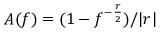Convert formula to latex. <formula><loc_0><loc_0><loc_500><loc_500>A ( f ) = ( 1 - f ^ { - \frac { r } { 2 } } ) / | r |</formula> 